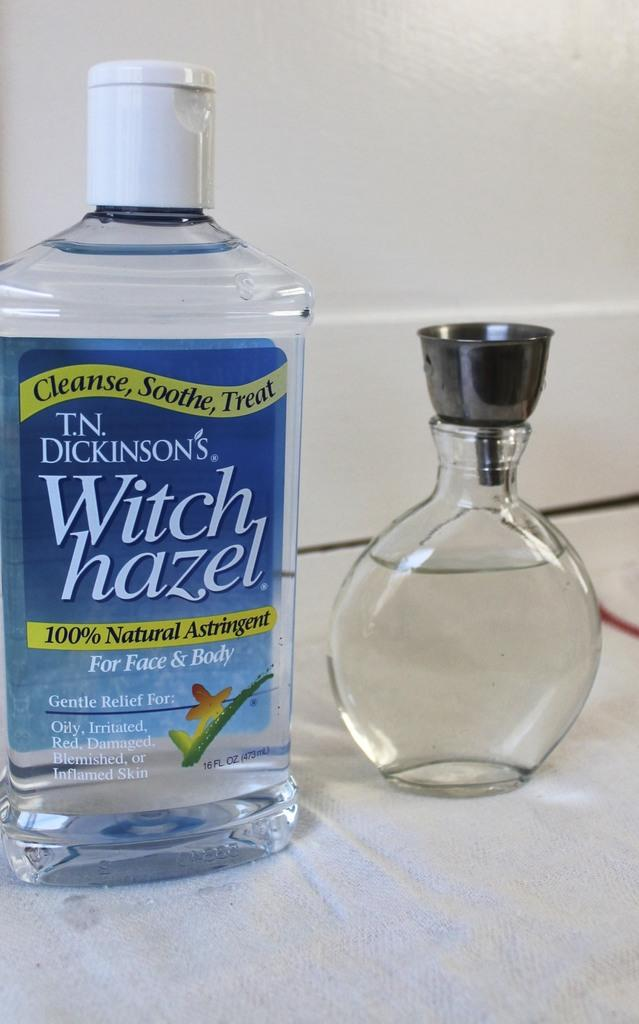<image>
Offer a succinct explanation of the picture presented. T.N. Dickinson's Witch Hazel provides relief for oily, irritated, red, damaged, blemished, or inflamed skin. 